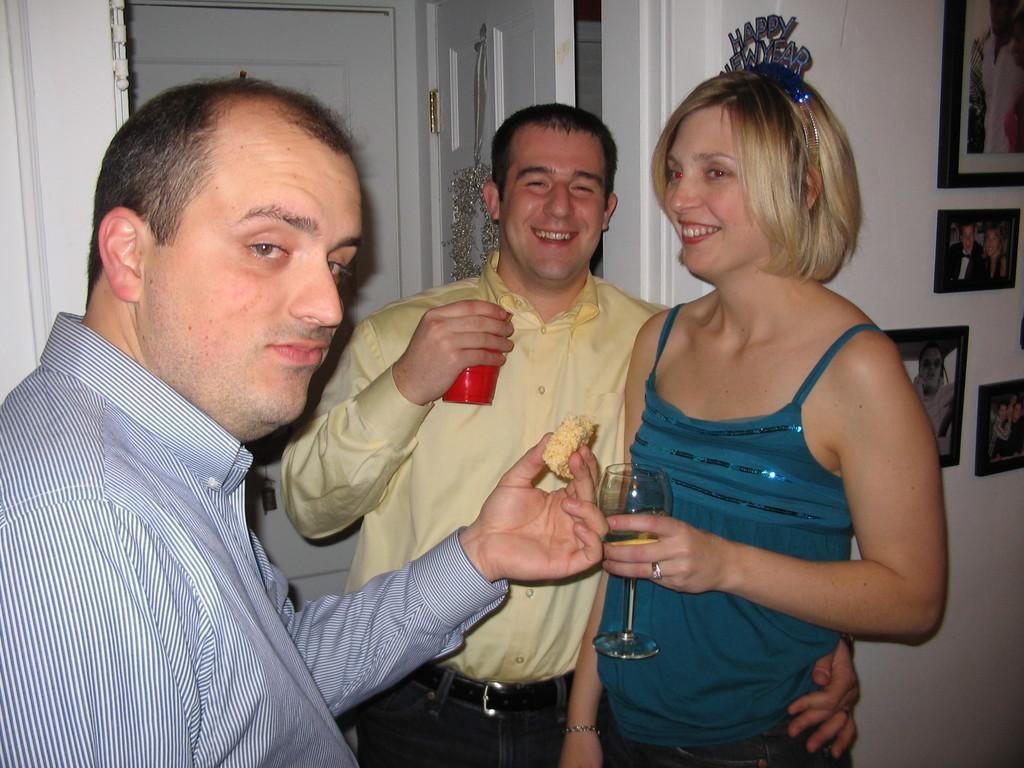Can you describe this image briefly? In this image we can see three people. These two people are holding glasses and smiling. This person is holding a food. Pictures are on the wall. 